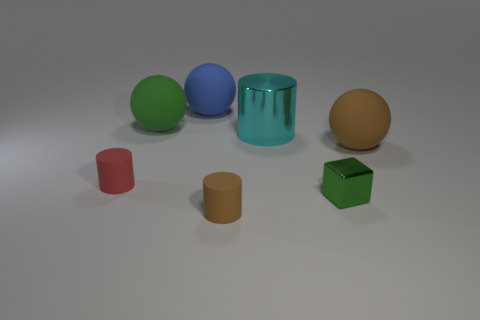Add 3 purple shiny cylinders. How many objects exist? 10 Subtract all cyan cylinders. How many cylinders are left? 2 Subtract all large metal cylinders. How many cylinders are left? 2 Subtract 0 cyan spheres. How many objects are left? 7 Subtract all spheres. How many objects are left? 4 Subtract 3 balls. How many balls are left? 0 Subtract all brown cubes. Subtract all yellow spheres. How many cubes are left? 1 Subtract all red cylinders. How many purple blocks are left? 0 Subtract all tiny green shiny cubes. Subtract all tiny cyan rubber cylinders. How many objects are left? 6 Add 2 big blue spheres. How many big blue spheres are left? 3 